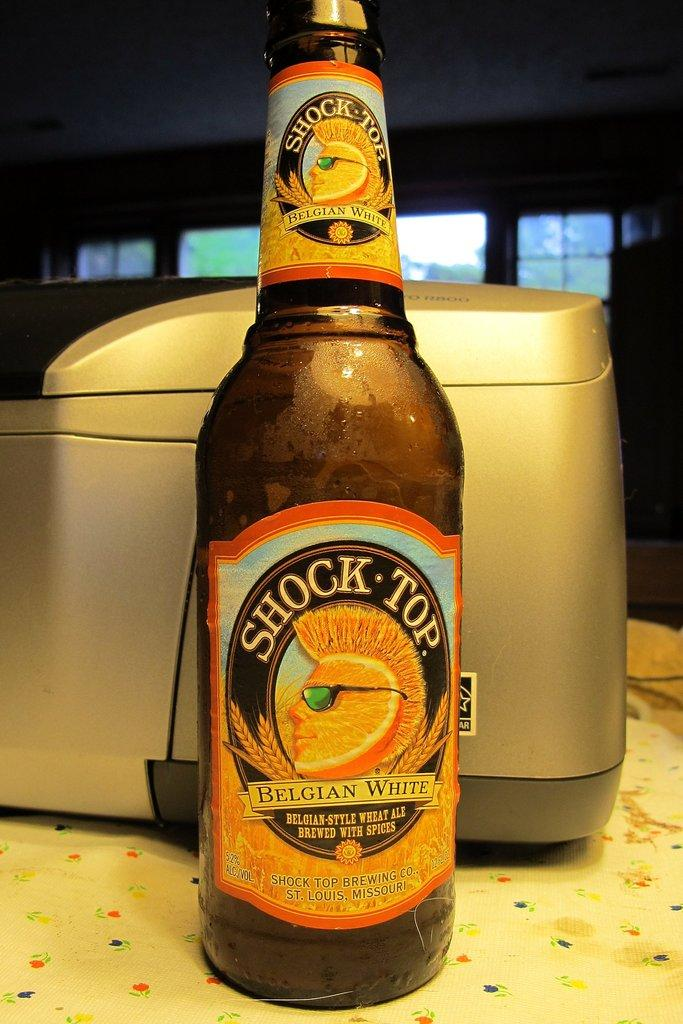<image>
Describe the image concisely. a shock top belgian white bottle standing in front of a printer 